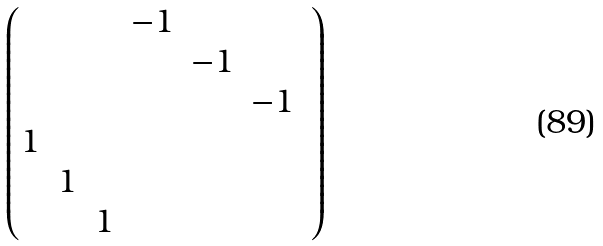<formula> <loc_0><loc_0><loc_500><loc_500>\begin{pmatrix} & & & - 1 & & \\ & & & & - 1 & \\ & & & & & - 1 & \\ 1 & & & & \\ & 1 & & & & \\ & & 1 & & & \\ \end{pmatrix}</formula> 